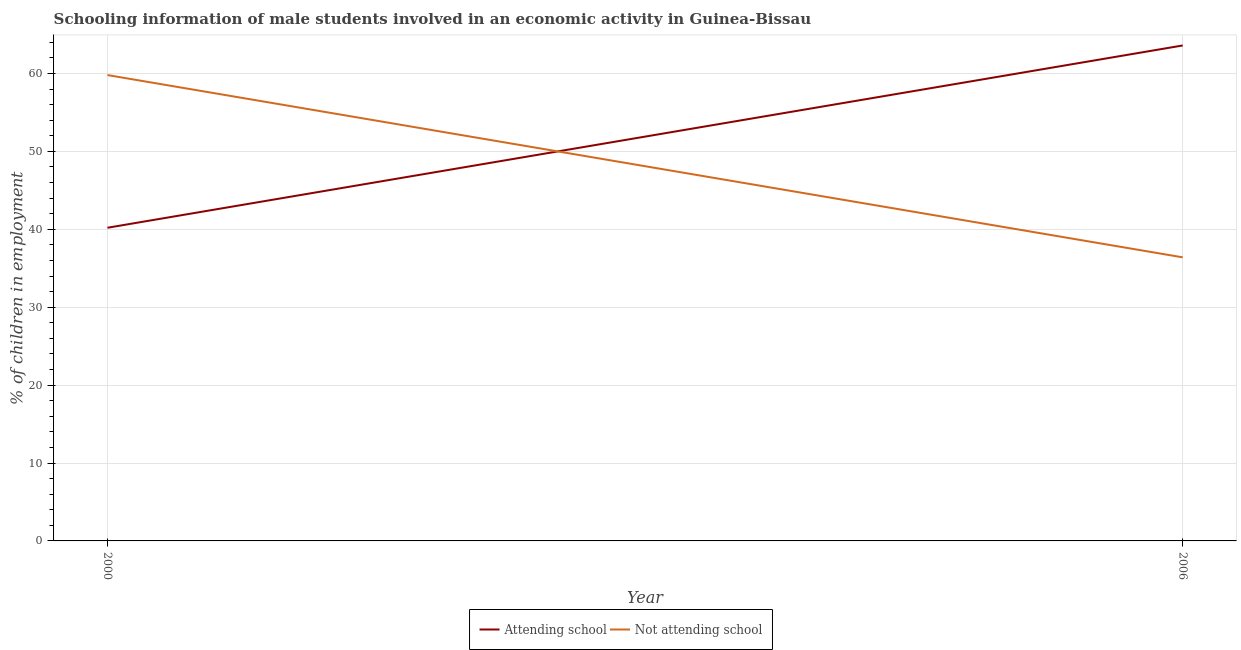Does the line corresponding to percentage of employed males who are not attending school intersect with the line corresponding to percentage of employed males who are attending school?
Make the answer very short. Yes. Is the number of lines equal to the number of legend labels?
Keep it short and to the point. Yes. What is the percentage of employed males who are not attending school in 2006?
Your answer should be very brief. 36.4. Across all years, what is the maximum percentage of employed males who are not attending school?
Your response must be concise. 59.8. Across all years, what is the minimum percentage of employed males who are attending school?
Provide a succinct answer. 40.2. In which year was the percentage of employed males who are not attending school maximum?
Your answer should be very brief. 2000. What is the total percentage of employed males who are attending school in the graph?
Ensure brevity in your answer.  103.8. What is the difference between the percentage of employed males who are attending school in 2000 and that in 2006?
Keep it short and to the point. -23.4. What is the difference between the percentage of employed males who are attending school in 2006 and the percentage of employed males who are not attending school in 2000?
Keep it short and to the point. 3.8. What is the average percentage of employed males who are attending school per year?
Keep it short and to the point. 51.9. In the year 2000, what is the difference between the percentage of employed males who are not attending school and percentage of employed males who are attending school?
Give a very brief answer. 19.6. In how many years, is the percentage of employed males who are attending school greater than 28 %?
Provide a short and direct response. 2. What is the ratio of the percentage of employed males who are not attending school in 2000 to that in 2006?
Your answer should be very brief. 1.64. In how many years, is the percentage of employed males who are attending school greater than the average percentage of employed males who are attending school taken over all years?
Offer a terse response. 1. Does the percentage of employed males who are attending school monotonically increase over the years?
Your answer should be very brief. Yes. Is the percentage of employed males who are not attending school strictly less than the percentage of employed males who are attending school over the years?
Make the answer very short. No. How many lines are there?
Ensure brevity in your answer.  2. How many years are there in the graph?
Keep it short and to the point. 2. What is the difference between two consecutive major ticks on the Y-axis?
Your answer should be compact. 10. Where does the legend appear in the graph?
Provide a succinct answer. Bottom center. What is the title of the graph?
Keep it short and to the point. Schooling information of male students involved in an economic activity in Guinea-Bissau. Does "Pregnant women" appear as one of the legend labels in the graph?
Your answer should be very brief. No. What is the label or title of the Y-axis?
Offer a terse response. % of children in employment. What is the % of children in employment of Attending school in 2000?
Give a very brief answer. 40.2. What is the % of children in employment in Not attending school in 2000?
Your response must be concise. 59.8. What is the % of children in employment of Attending school in 2006?
Give a very brief answer. 63.6. What is the % of children in employment in Not attending school in 2006?
Your answer should be compact. 36.4. Across all years, what is the maximum % of children in employment of Attending school?
Make the answer very short. 63.6. Across all years, what is the maximum % of children in employment of Not attending school?
Your answer should be compact. 59.8. Across all years, what is the minimum % of children in employment in Attending school?
Provide a short and direct response. 40.2. Across all years, what is the minimum % of children in employment in Not attending school?
Ensure brevity in your answer.  36.4. What is the total % of children in employment in Attending school in the graph?
Ensure brevity in your answer.  103.8. What is the total % of children in employment of Not attending school in the graph?
Provide a short and direct response. 96.2. What is the difference between the % of children in employment in Attending school in 2000 and that in 2006?
Provide a short and direct response. -23.4. What is the difference between the % of children in employment in Not attending school in 2000 and that in 2006?
Offer a terse response. 23.4. What is the average % of children in employment of Attending school per year?
Ensure brevity in your answer.  51.9. What is the average % of children in employment in Not attending school per year?
Make the answer very short. 48.1. In the year 2000, what is the difference between the % of children in employment in Attending school and % of children in employment in Not attending school?
Make the answer very short. -19.6. In the year 2006, what is the difference between the % of children in employment in Attending school and % of children in employment in Not attending school?
Ensure brevity in your answer.  27.2. What is the ratio of the % of children in employment of Attending school in 2000 to that in 2006?
Offer a terse response. 0.63. What is the ratio of the % of children in employment of Not attending school in 2000 to that in 2006?
Ensure brevity in your answer.  1.64. What is the difference between the highest and the second highest % of children in employment of Attending school?
Provide a succinct answer. 23.4. What is the difference between the highest and the second highest % of children in employment in Not attending school?
Keep it short and to the point. 23.4. What is the difference between the highest and the lowest % of children in employment of Attending school?
Offer a terse response. 23.4. What is the difference between the highest and the lowest % of children in employment of Not attending school?
Ensure brevity in your answer.  23.4. 